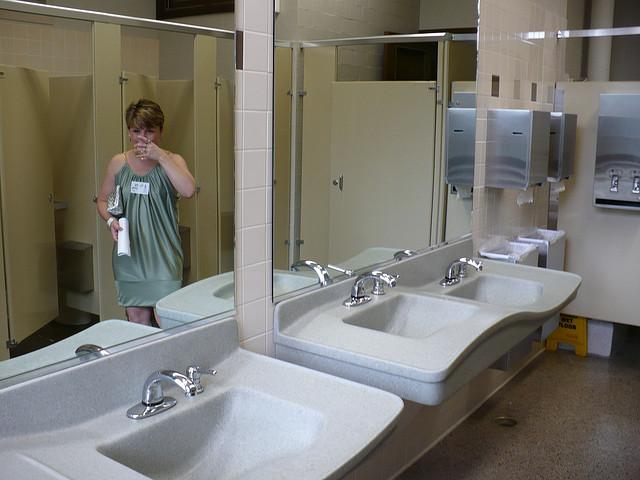What color dress is she wearing?
Be succinct. Green. How many mirrors are in the picture?
Short answer required. 2. How many sinks are visible?
Answer briefly. 3. 